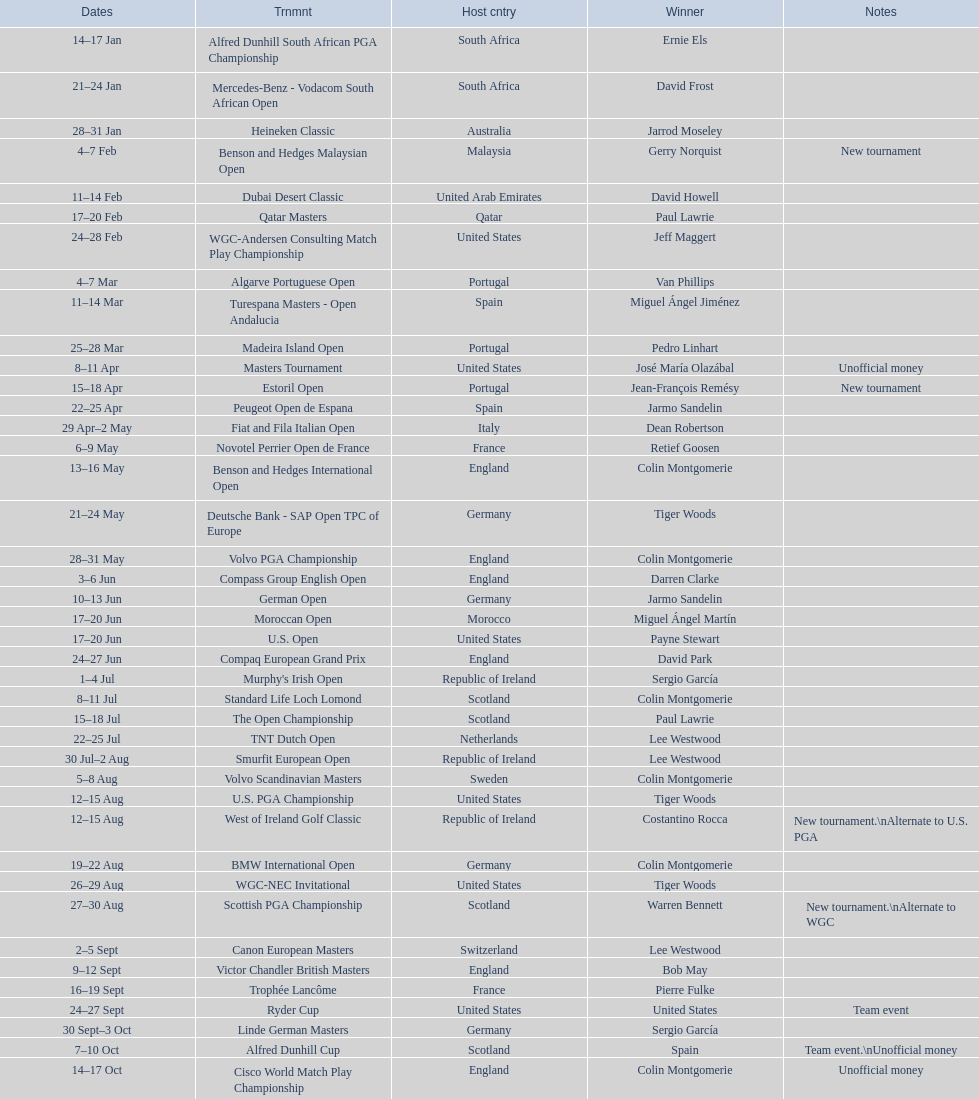Other than qatar masters, name a tournament that was in february. Dubai Desert Classic. 